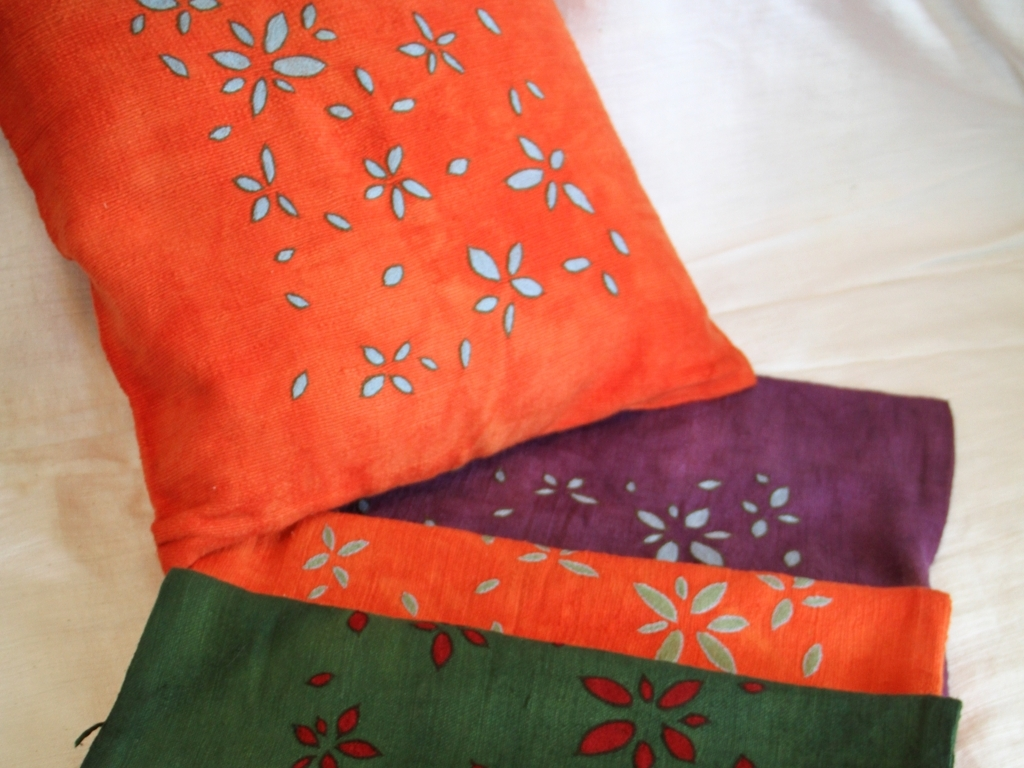Can you describe the patterns on these fabrics? Certainly! The fabrics feature a repeated floral-like pattern with what appears to be a leaf motif. The designs are simple yet elegant, creating a sense of harmony and rhythm across the material. 